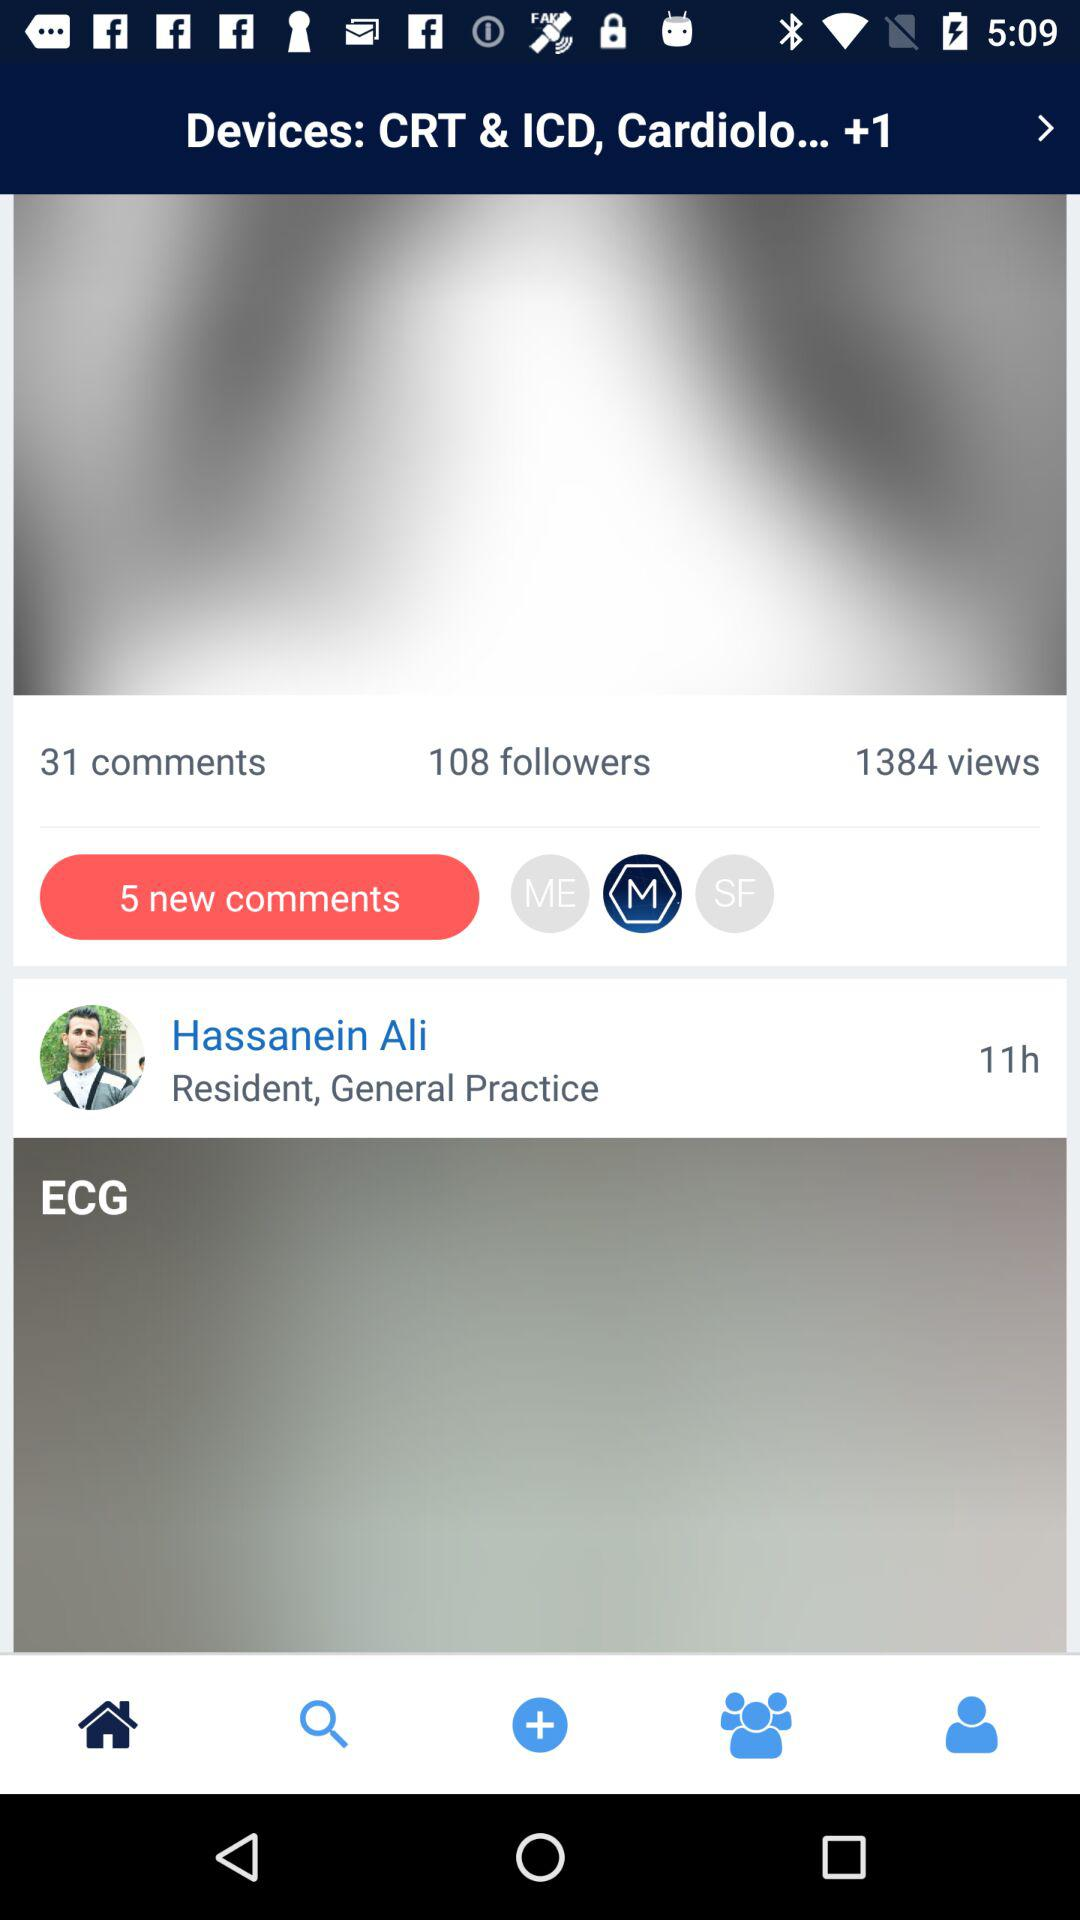How many views are there? There are 1384 views. 